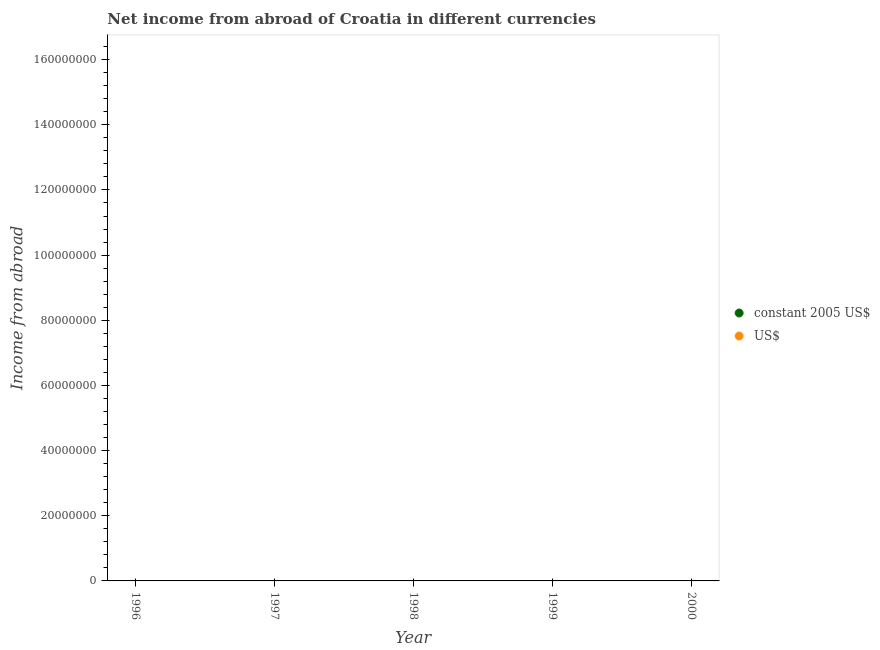How many different coloured dotlines are there?
Your response must be concise. 0. Is the number of dotlines equal to the number of legend labels?
Your response must be concise. No. Across all years, what is the minimum income from abroad in constant 2005 us$?
Your answer should be very brief. 0. What is the total income from abroad in us$ in the graph?
Give a very brief answer. 0. What is the average income from abroad in constant 2005 us$ per year?
Offer a very short reply. 0. In how many years, is the income from abroad in us$ greater than the average income from abroad in us$ taken over all years?
Your answer should be compact. 0. Is the income from abroad in constant 2005 us$ strictly greater than the income from abroad in us$ over the years?
Offer a very short reply. No. How many dotlines are there?
Offer a very short reply. 0. How many years are there in the graph?
Offer a very short reply. 5. Where does the legend appear in the graph?
Provide a short and direct response. Center right. How many legend labels are there?
Offer a terse response. 2. What is the title of the graph?
Give a very brief answer. Net income from abroad of Croatia in different currencies. What is the label or title of the X-axis?
Keep it short and to the point. Year. What is the label or title of the Y-axis?
Make the answer very short. Income from abroad. What is the Income from abroad of constant 2005 US$ in 1996?
Your answer should be compact. 0. What is the Income from abroad of US$ in 1996?
Give a very brief answer. 0. What is the Income from abroad in constant 2005 US$ in 1997?
Make the answer very short. 0. What is the Income from abroad in US$ in 1997?
Give a very brief answer. 0. What is the Income from abroad in US$ in 2000?
Your response must be concise. 0. What is the total Income from abroad of constant 2005 US$ in the graph?
Your response must be concise. 0. What is the average Income from abroad in constant 2005 US$ per year?
Ensure brevity in your answer.  0. What is the average Income from abroad in US$ per year?
Offer a very short reply. 0. 